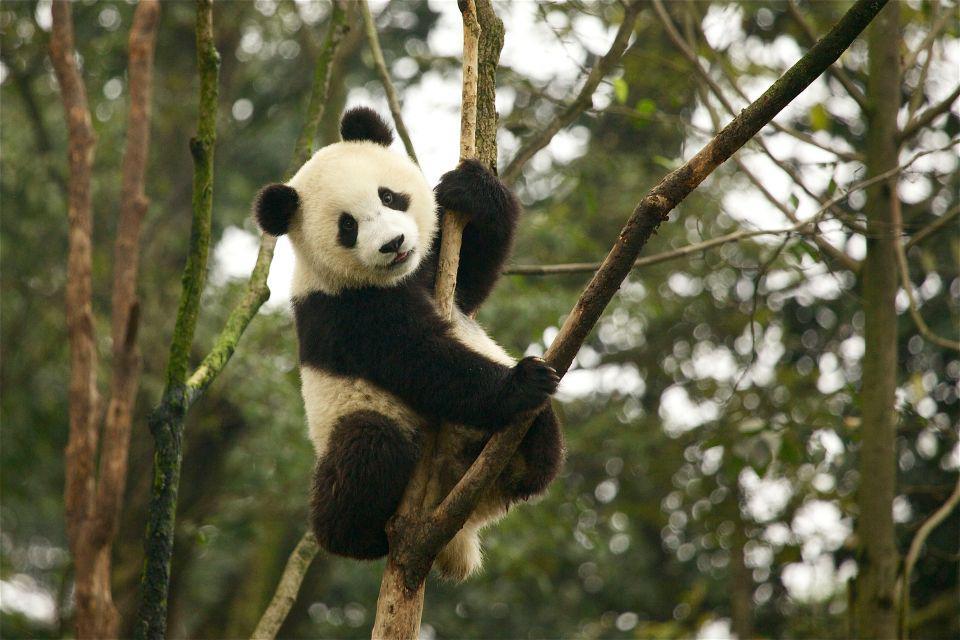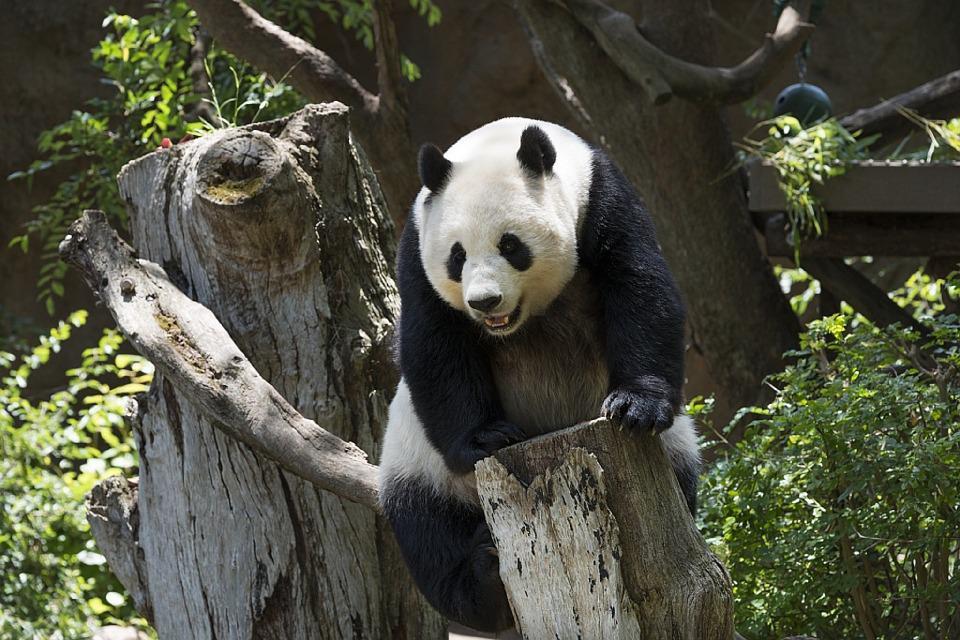The first image is the image on the left, the second image is the image on the right. Assess this claim about the two images: "Each image features a panda in a tree". Correct or not? Answer yes or no. Yes. The first image is the image on the left, the second image is the image on the right. Given the left and right images, does the statement "Each image shows one panda perched off the ground in something tree-like, and at least one image shows a panda with front paws around a forking tree limb." hold true? Answer yes or no. Yes. 